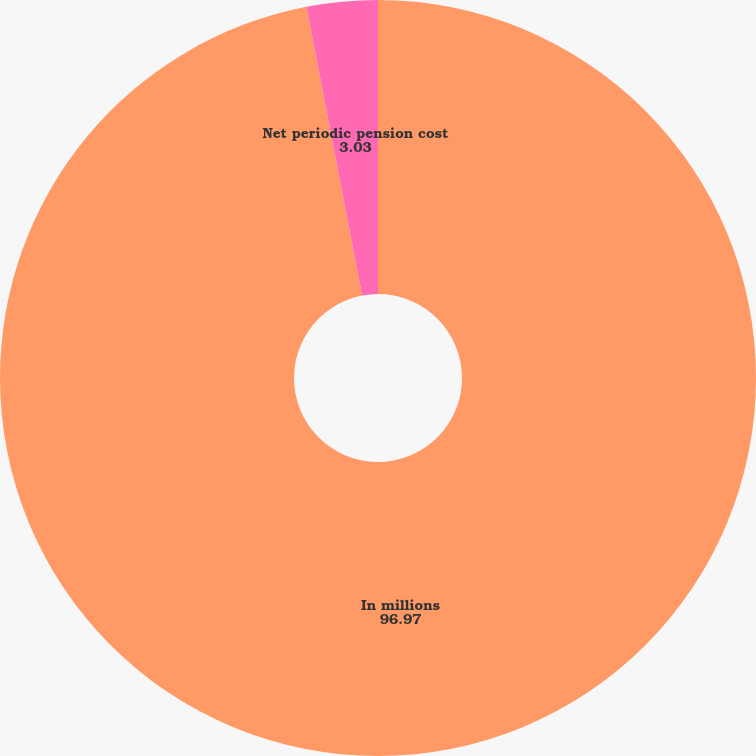<chart> <loc_0><loc_0><loc_500><loc_500><pie_chart><fcel>In millions<fcel>Net periodic pension cost<nl><fcel>96.97%<fcel>3.03%<nl></chart> 